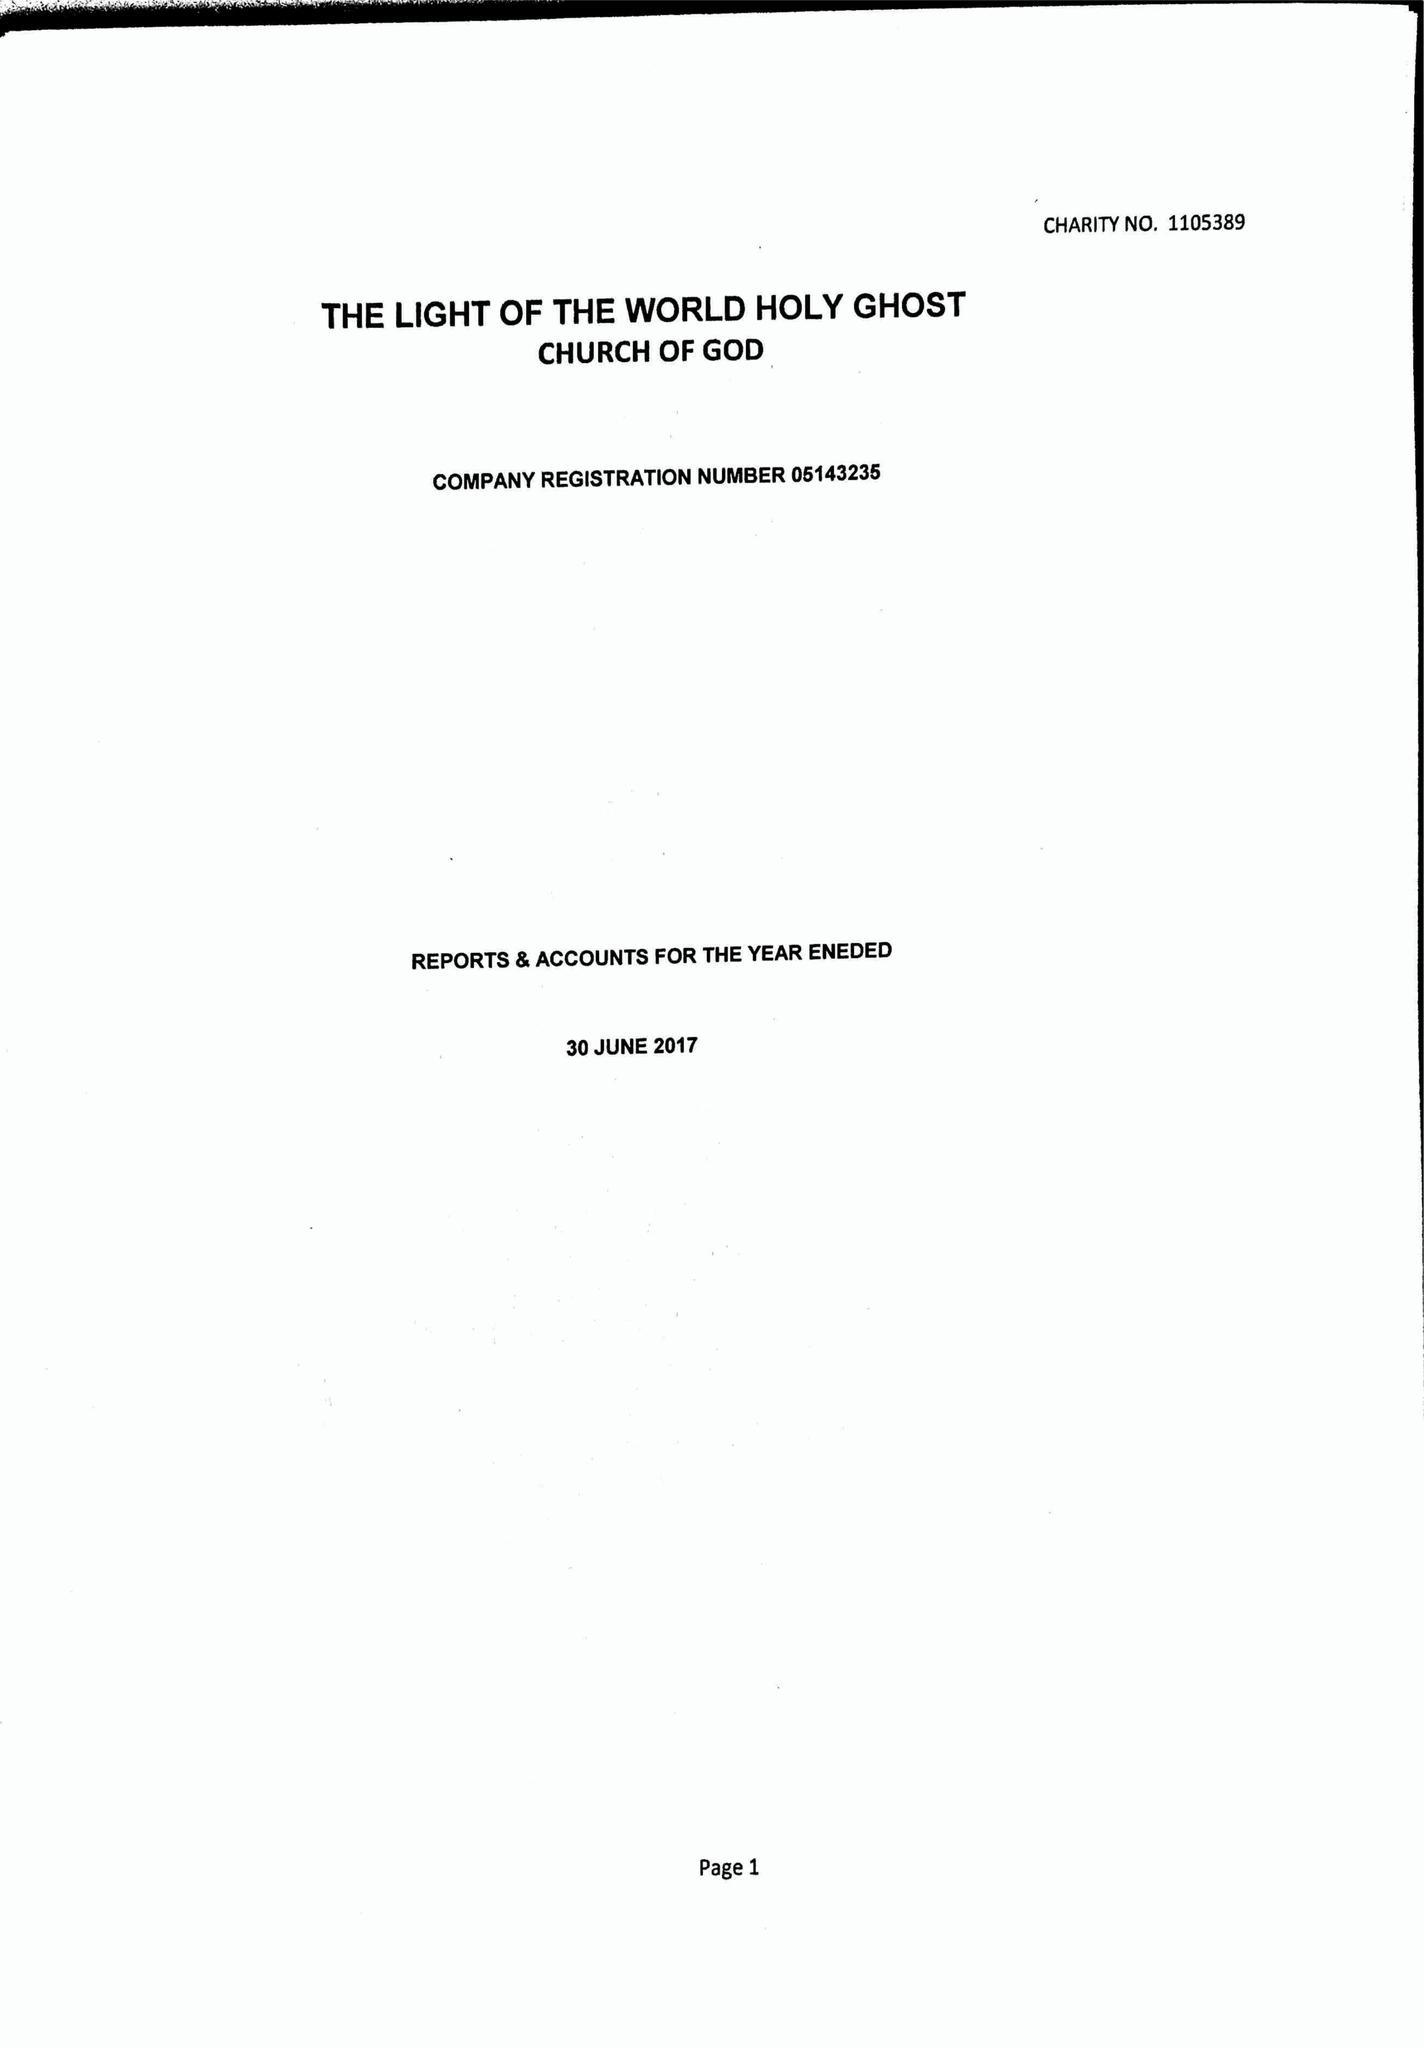What is the value for the spending_annually_in_british_pounds?
Answer the question using a single word or phrase. 26611.00 